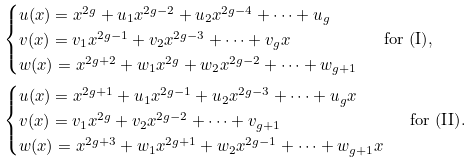Convert formula to latex. <formula><loc_0><loc_0><loc_500><loc_500>& \begin{cases} u ( x ) = x ^ { 2 g } + u _ { 1 } x ^ { 2 g - 2 } + u _ { 2 } x ^ { 2 g - 4 } + \cdots + u _ { g } \\ v ( x ) = v _ { 1 } x ^ { 2 g - 1 } + v _ { 2 } x ^ { 2 g - 3 } + \cdots + v _ { g } x \\ w ( x ) = x ^ { 2 g + 2 } + w _ { 1 } x ^ { 2 g } + w _ { 2 } x ^ { 2 g - 2 } + \cdots + w _ { g + 1 } \end{cases} \text { for (I)} , \\ & \begin{cases} u ( x ) = x ^ { 2 g + 1 } + u _ { 1 } x ^ { 2 g - 1 } + u _ { 2 } x ^ { 2 g - 3 } + \cdots + u _ { g } x \\ v ( x ) = v _ { 1 } x ^ { 2 g } + v _ { 2 } x ^ { 2 g - 2 } + \cdots + v _ { g + 1 } \\ w ( x ) = x ^ { 2 g + 3 } + w _ { 1 } x ^ { 2 g + 1 } + w _ { 2 } x ^ { 2 g - 1 } + \cdots + w _ { g + 1 } x \end{cases} \text { for (II)} .</formula> 